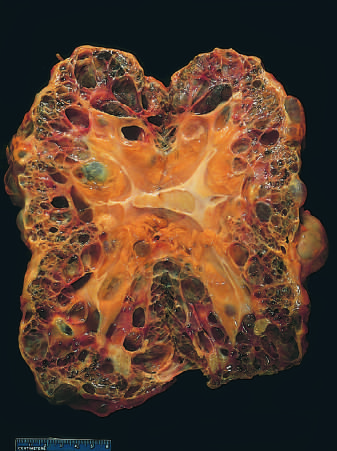s centimeter rule shown for scale?
Answer the question using a single word or phrase. Yes 